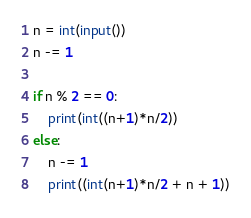Convert code to text. <code><loc_0><loc_0><loc_500><loc_500><_Python_>n = int(input())
n -= 1

if n % 2 == 0:
    print(int((n+1)*n/2))
else:
    n -= 1
    print((int(n+1)*n/2 + n + 1))
</code> 